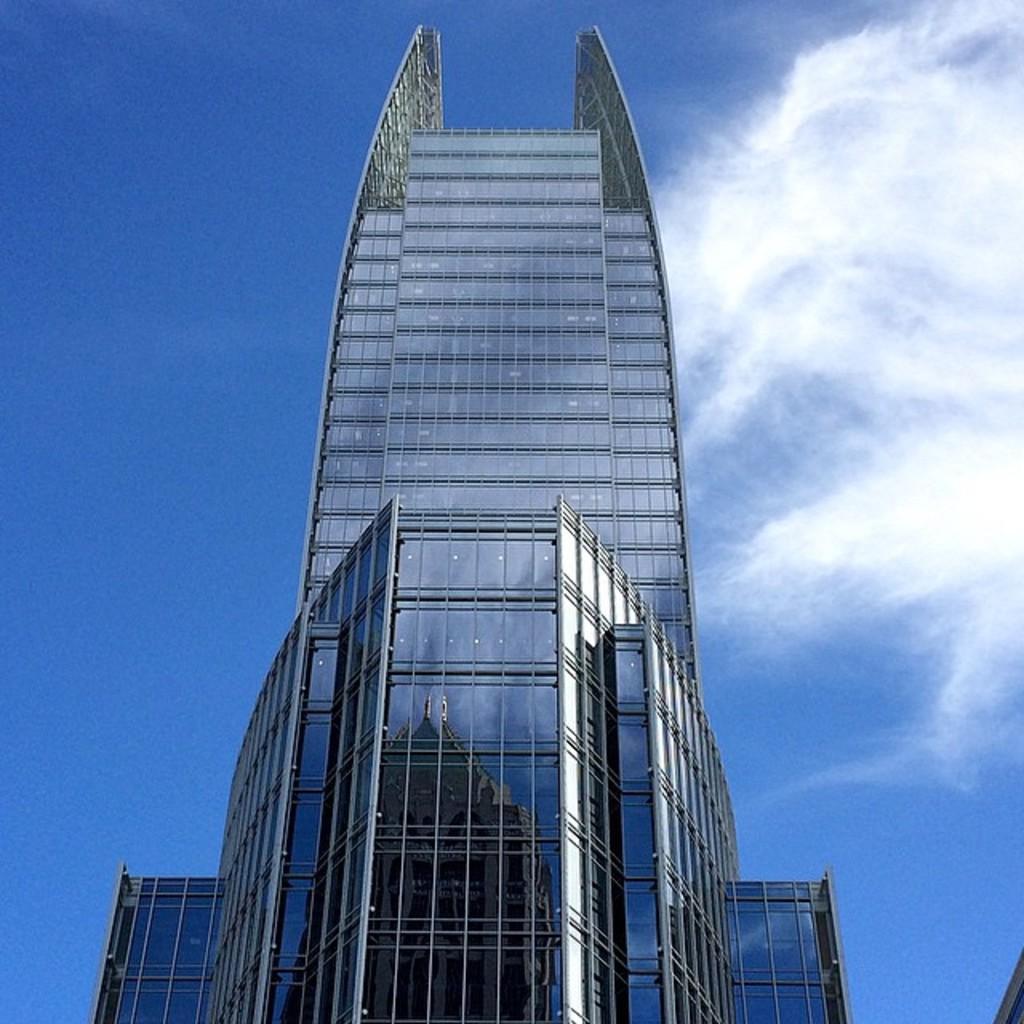Please provide a concise description of this image. In the picture I can see the glass tower building in the middle of the image. There are clouds in the sky. 